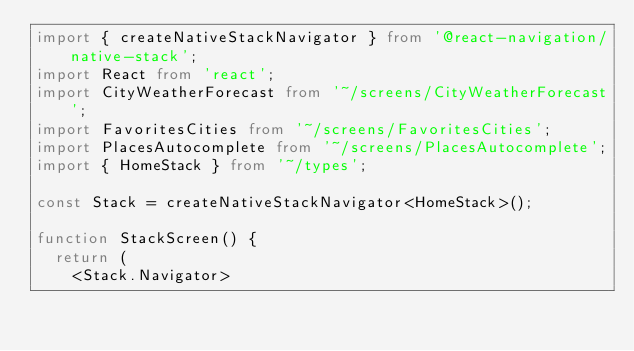<code> <loc_0><loc_0><loc_500><loc_500><_TypeScript_>import { createNativeStackNavigator } from '@react-navigation/native-stack';
import React from 'react';
import CityWeatherForecast from '~/screens/CityWeatherForecast';
import FavoritesCities from '~/screens/FavoritesCities';
import PlacesAutocomplete from '~/screens/PlacesAutocomplete';
import { HomeStack } from '~/types';

const Stack = createNativeStackNavigator<HomeStack>();

function StackScreen() {
  return (
    <Stack.Navigator></code> 